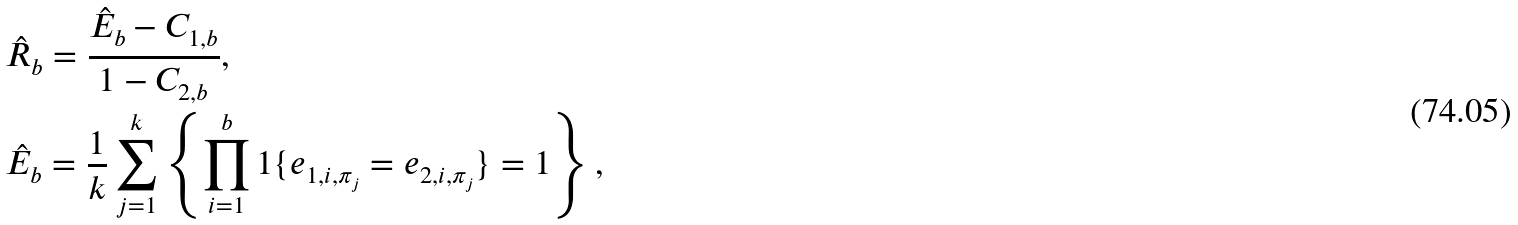Convert formula to latex. <formula><loc_0><loc_0><loc_500><loc_500>& \hat { R } _ { b } = \frac { \hat { E } _ { b } - C _ { 1 , b } } { 1 - C _ { 2 , b } } , \\ & \hat { E } _ { b } = \frac { 1 } { k } \sum _ { j = 1 } ^ { k } \left \{ \prod _ { i = 1 } ^ { b } 1 \{ e _ { 1 , i , \pi _ { j } } = e _ { 2 , i , \pi _ { j } } \} = 1 \right \} ,</formula> 